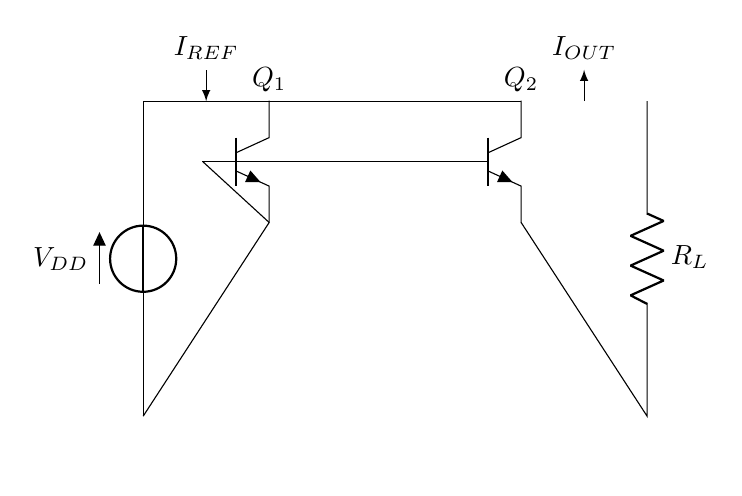What is the type of the transistors in this circuit? The transistors are labeled as NP and P, indicating they are NPN type transistors. This can be determined from the labels on the circuit diagram.
Answer: NPN What does the label R_L represent in this circuit? R_L is labeled as a resistor connected to the output of the circuit, indicating it is the load resistor for the output current.
Answer: Load resistor What is the function of Q1 in this current mirror circuit? Q1 serves as the reference current generator by mirroring the current into Q2, allowing for stable output current at Q2. This function is identified by its position and connection to the supply and other transistor.
Answer: Current generator How many connections are there to the ground in this circuit? There are two connections to the ground as indicated by the connections coming from the emitters of the transistors Q1 and Q2 leading down to the ground node.
Answer: Two What is the reference current denoted in the circuit? The reference current is shown as I_REF, which flows through Q1 and sets the current level that Q2 mirrors. This is indicated by the label above the connection from Q1.
Answer: I_REF What is the purpose of the current mirror in this circuit? The current mirror's purpose is to provide a stable current for communication devices irrespective of variations in voltage supply or load, as indicated by the labeling in the circuit diagram.
Answer: Stable current What is the voltage supply for this circuit? The voltage supply is denoted as V_DD in the circuit diagram, providing power for the transistors to operate. This is visible at the top of the circuit where the source is labeled.
Answer: V_DD 